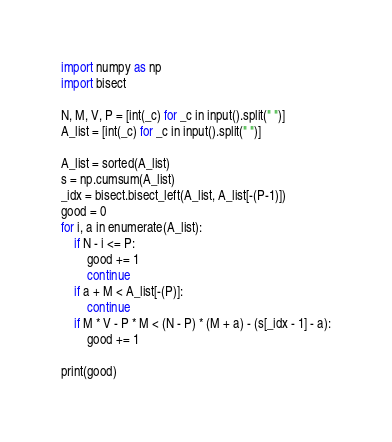<code> <loc_0><loc_0><loc_500><loc_500><_Python_>import numpy as np
import bisect

N, M, V, P = [int(_c) for _c in input().split(" ")]
A_list = [int(_c) for _c in input().split(" ")]

A_list = sorted(A_list)
s = np.cumsum(A_list)
_idx = bisect.bisect_left(A_list, A_list[-(P-1)])
good = 0
for i, a in enumerate(A_list):
    if N - i <= P:
        good += 1
        continue
    if a + M < A_list[-(P)]:
        continue
    if M * V - P * M < (N - P) * (M + a) - (s[_idx - 1] - a):
        good += 1

print(good)</code> 